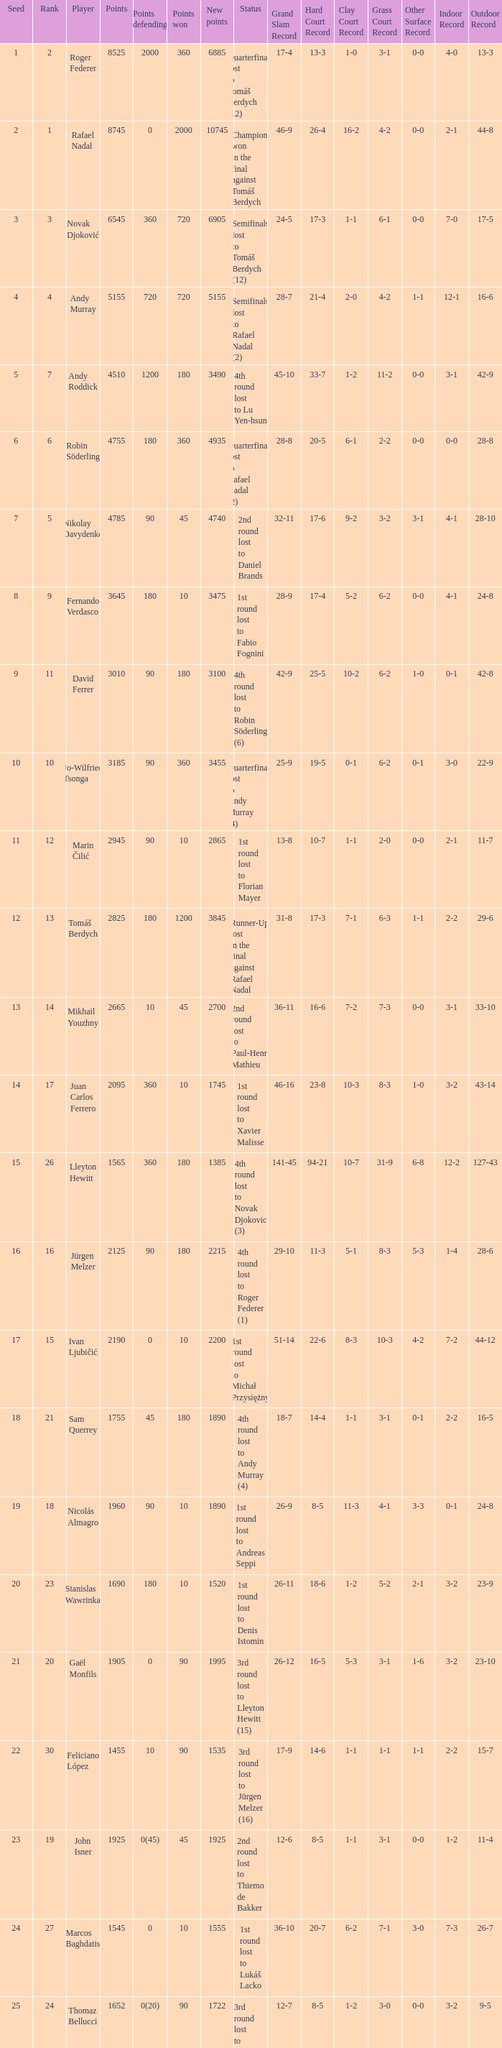Name the least new points for points defending is 1200 3490.0. 